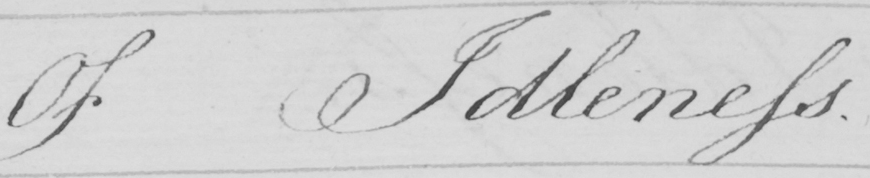Transcribe the text shown in this historical manuscript line. Of Idleness . 